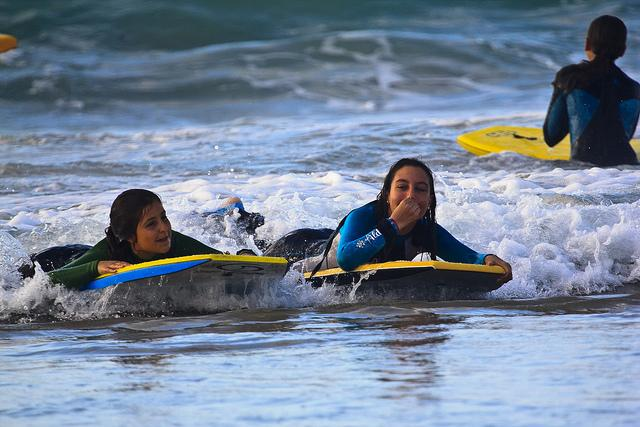Why are they lying down? resting 